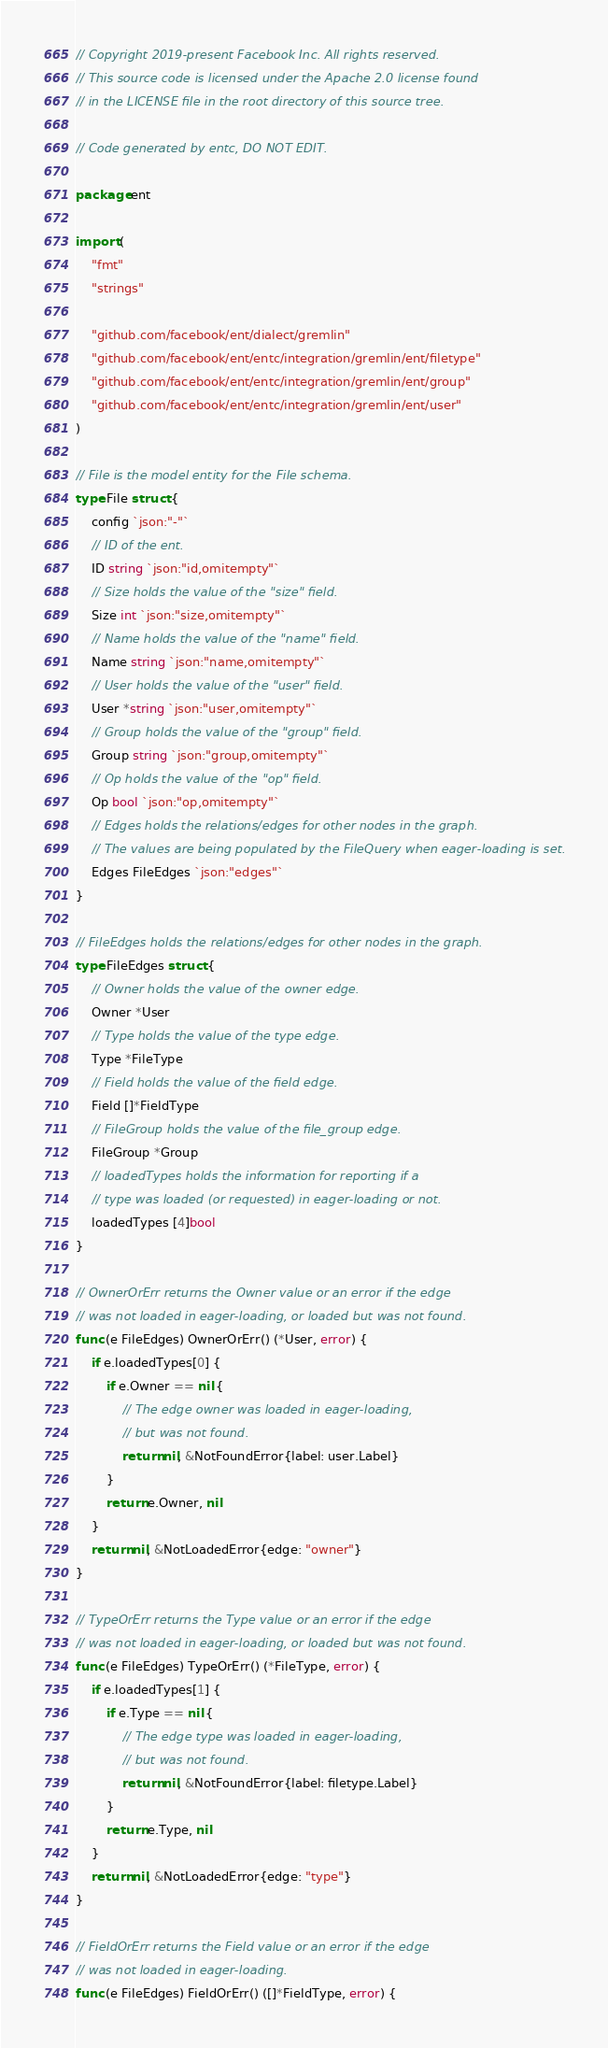<code> <loc_0><loc_0><loc_500><loc_500><_Go_>// Copyright 2019-present Facebook Inc. All rights reserved.
// This source code is licensed under the Apache 2.0 license found
// in the LICENSE file in the root directory of this source tree.

// Code generated by entc, DO NOT EDIT.

package ent

import (
	"fmt"
	"strings"

	"github.com/facebook/ent/dialect/gremlin"
	"github.com/facebook/ent/entc/integration/gremlin/ent/filetype"
	"github.com/facebook/ent/entc/integration/gremlin/ent/group"
	"github.com/facebook/ent/entc/integration/gremlin/ent/user"
)

// File is the model entity for the File schema.
type File struct {
	config `json:"-"`
	// ID of the ent.
	ID string `json:"id,omitempty"`
	// Size holds the value of the "size" field.
	Size int `json:"size,omitempty"`
	// Name holds the value of the "name" field.
	Name string `json:"name,omitempty"`
	// User holds the value of the "user" field.
	User *string `json:"user,omitempty"`
	// Group holds the value of the "group" field.
	Group string `json:"group,omitempty"`
	// Op holds the value of the "op" field.
	Op bool `json:"op,omitempty"`
	// Edges holds the relations/edges for other nodes in the graph.
	// The values are being populated by the FileQuery when eager-loading is set.
	Edges FileEdges `json:"edges"`
}

// FileEdges holds the relations/edges for other nodes in the graph.
type FileEdges struct {
	// Owner holds the value of the owner edge.
	Owner *User
	// Type holds the value of the type edge.
	Type *FileType
	// Field holds the value of the field edge.
	Field []*FieldType
	// FileGroup holds the value of the file_group edge.
	FileGroup *Group
	// loadedTypes holds the information for reporting if a
	// type was loaded (or requested) in eager-loading or not.
	loadedTypes [4]bool
}

// OwnerOrErr returns the Owner value or an error if the edge
// was not loaded in eager-loading, or loaded but was not found.
func (e FileEdges) OwnerOrErr() (*User, error) {
	if e.loadedTypes[0] {
		if e.Owner == nil {
			// The edge owner was loaded in eager-loading,
			// but was not found.
			return nil, &NotFoundError{label: user.Label}
		}
		return e.Owner, nil
	}
	return nil, &NotLoadedError{edge: "owner"}
}

// TypeOrErr returns the Type value or an error if the edge
// was not loaded in eager-loading, or loaded but was not found.
func (e FileEdges) TypeOrErr() (*FileType, error) {
	if e.loadedTypes[1] {
		if e.Type == nil {
			// The edge type was loaded in eager-loading,
			// but was not found.
			return nil, &NotFoundError{label: filetype.Label}
		}
		return e.Type, nil
	}
	return nil, &NotLoadedError{edge: "type"}
}

// FieldOrErr returns the Field value or an error if the edge
// was not loaded in eager-loading.
func (e FileEdges) FieldOrErr() ([]*FieldType, error) {</code> 